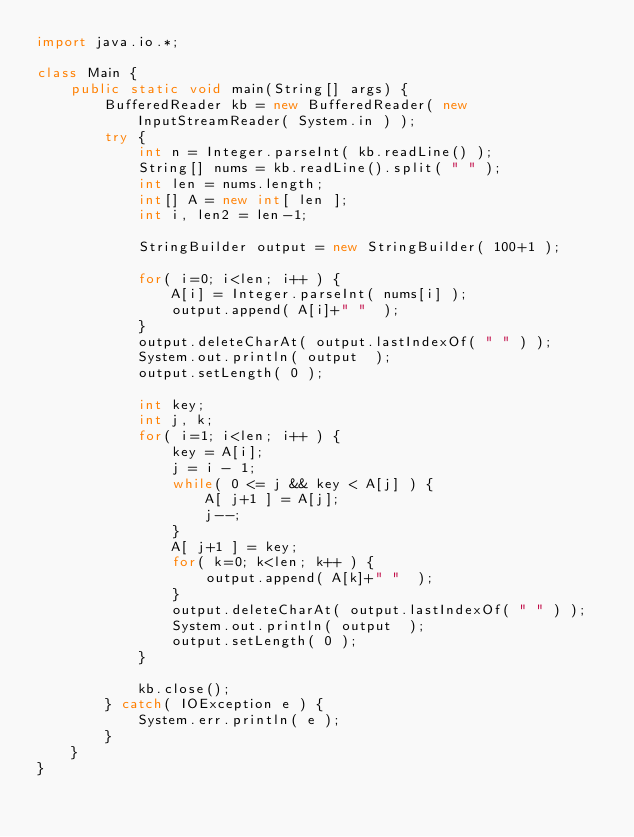Convert code to text. <code><loc_0><loc_0><loc_500><loc_500><_Java_>import java.io.*;

class Main {
	public static void main(String[] args) {
		BufferedReader kb = new BufferedReader( new InputStreamReader( System.in ) );
		try {
			int n = Integer.parseInt( kb.readLine() );
			String[] nums = kb.readLine().split( " " );
			int len = nums.length;
			int[] A = new int[ len ];
			int i, len2 = len-1;

			StringBuilder output = new StringBuilder( 100+1 );									
			for( i=0; i<len; i++ ) {
				A[i] = Integer.parseInt( nums[i] );
				output.append( A[i]+" "  );
			}
			output.deleteCharAt( output.lastIndexOf( " " ) );
			System.out.println( output  );
			output.setLength( 0 );

			int key;
			int j, k;
 			for( i=1; i<len; i++ ) {
				key = A[i];
				j = i - 1;
				while( 0 <= j && key < A[j] ) {
					A[ j+1 ] = A[j];
					j--;
				}
				A[ j+1 ] = key;
				for( k=0; k<len; k++ ) {
					output.append( A[k]+" "  );
				}
				output.deleteCharAt( output.lastIndexOf( " " ) );
				System.out.println( output  );
				output.setLength( 0 );
			}
			
 			kb.close();
		} catch( IOException e ) {
			System.err.println( e );
		}
	}
}</code> 